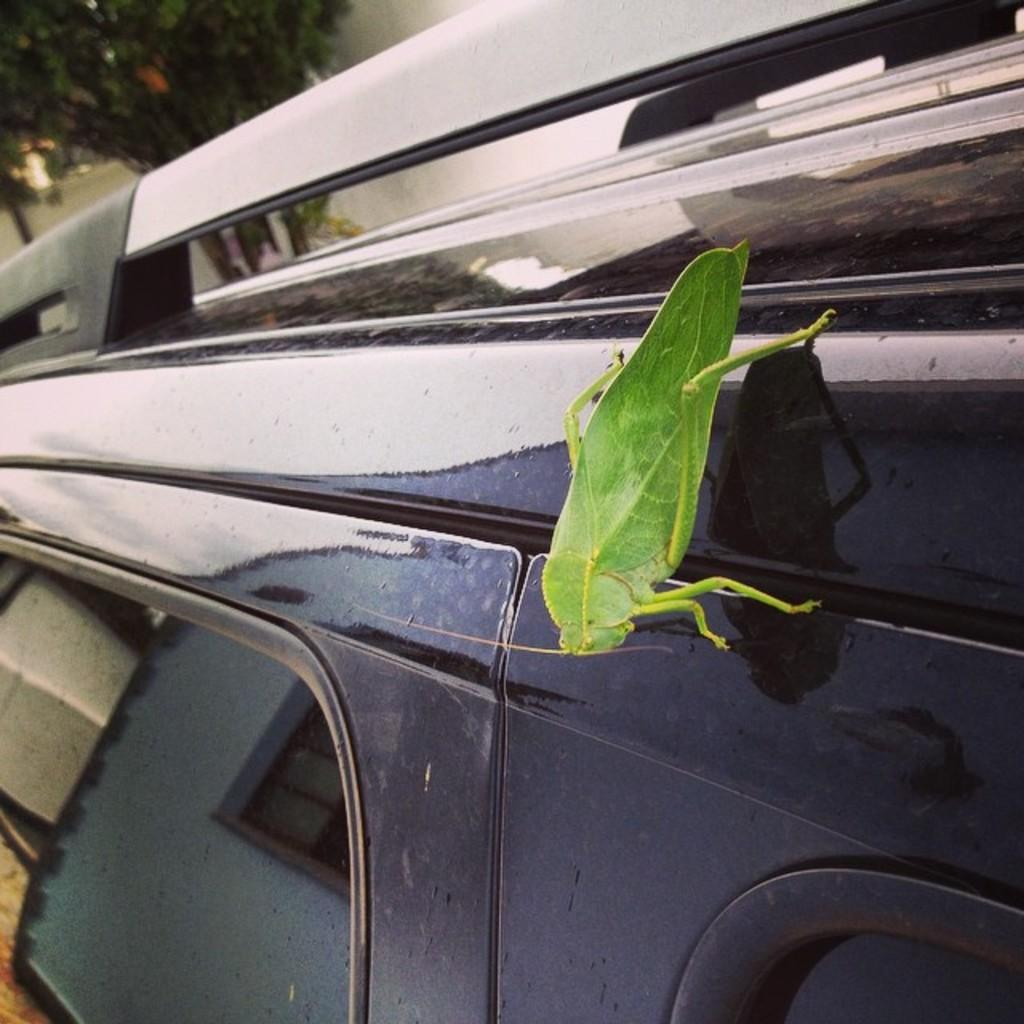What is the main subject of the image? There is an insect on a vehicle in the image. Where is the insect located on the vehicle? The insect is in the middle of the image. What can be seen in the top left corner of the image? There is a tree visible in the top left corner of the image. What is the name of the duck that is sitting next to the insect in the image? There is no duck present in the image; it only features an insect on a vehicle. 